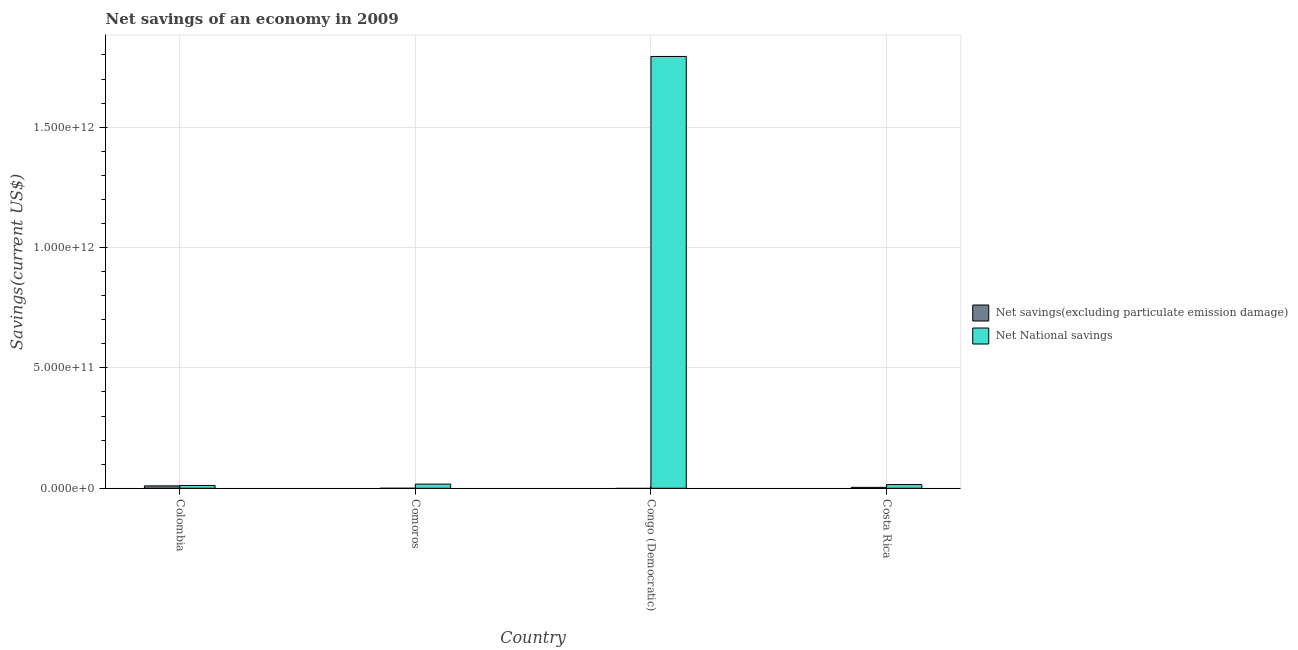Are the number of bars per tick equal to the number of legend labels?
Keep it short and to the point. No. How many bars are there on the 3rd tick from the left?
Give a very brief answer. 1. In how many cases, is the number of bars for a given country not equal to the number of legend labels?
Give a very brief answer. 2. What is the net national savings in Colombia?
Your answer should be compact. 1.17e+1. Across all countries, what is the maximum net savings(excluding particulate emission damage)?
Provide a succinct answer. 9.97e+09. Across all countries, what is the minimum net national savings?
Your response must be concise. 1.17e+1. In which country was the net national savings maximum?
Keep it short and to the point. Congo (Democratic). What is the total net savings(excluding particulate emission damage) in the graph?
Provide a short and direct response. 1.39e+1. What is the difference between the net national savings in Congo (Democratic) and that in Costa Rica?
Keep it short and to the point. 1.78e+12. What is the difference between the net savings(excluding particulate emission damage) in Comoros and the net national savings in Colombia?
Make the answer very short. -1.17e+1. What is the average net savings(excluding particulate emission damage) per country?
Offer a very short reply. 3.47e+09. What is the difference between the net national savings and net savings(excluding particulate emission damage) in Colombia?
Keep it short and to the point. 1.73e+09. In how many countries, is the net national savings greater than 1700000000000 US$?
Offer a terse response. 1. What is the ratio of the net national savings in Colombia to that in Costa Rica?
Offer a terse response. 0.76. Is the difference between the net savings(excluding particulate emission damage) in Colombia and Costa Rica greater than the difference between the net national savings in Colombia and Costa Rica?
Your answer should be compact. Yes. What is the difference between the highest and the second highest net national savings?
Ensure brevity in your answer.  1.78e+12. What is the difference between the highest and the lowest net savings(excluding particulate emission damage)?
Your answer should be very brief. 9.97e+09. In how many countries, is the net national savings greater than the average net national savings taken over all countries?
Provide a succinct answer. 1. How many bars are there?
Your answer should be compact. 6. How many countries are there in the graph?
Keep it short and to the point. 4. What is the difference between two consecutive major ticks on the Y-axis?
Provide a short and direct response. 5.00e+11. Does the graph contain any zero values?
Provide a succinct answer. Yes. Does the graph contain grids?
Your answer should be very brief. Yes. Where does the legend appear in the graph?
Offer a terse response. Center right. How many legend labels are there?
Offer a very short reply. 2. What is the title of the graph?
Your answer should be compact. Net savings of an economy in 2009. Does "Subsidies" appear as one of the legend labels in the graph?
Provide a short and direct response. No. What is the label or title of the X-axis?
Give a very brief answer. Country. What is the label or title of the Y-axis?
Provide a succinct answer. Savings(current US$). What is the Savings(current US$) of Net savings(excluding particulate emission damage) in Colombia?
Keep it short and to the point. 9.97e+09. What is the Savings(current US$) in Net National savings in Colombia?
Your answer should be compact. 1.17e+1. What is the Savings(current US$) in Net savings(excluding particulate emission damage) in Comoros?
Offer a terse response. 0. What is the Savings(current US$) in Net National savings in Comoros?
Offer a very short reply. 1.74e+1. What is the Savings(current US$) in Net savings(excluding particulate emission damage) in Congo (Democratic)?
Offer a terse response. 0. What is the Savings(current US$) in Net National savings in Congo (Democratic)?
Your answer should be very brief. 1.79e+12. What is the Savings(current US$) in Net savings(excluding particulate emission damage) in Costa Rica?
Provide a short and direct response. 3.89e+09. What is the Savings(current US$) of Net National savings in Costa Rica?
Make the answer very short. 1.53e+1. Across all countries, what is the maximum Savings(current US$) of Net savings(excluding particulate emission damage)?
Give a very brief answer. 9.97e+09. Across all countries, what is the maximum Savings(current US$) in Net National savings?
Your answer should be compact. 1.79e+12. Across all countries, what is the minimum Savings(current US$) of Net savings(excluding particulate emission damage)?
Provide a short and direct response. 0. Across all countries, what is the minimum Savings(current US$) in Net National savings?
Your answer should be compact. 1.17e+1. What is the total Savings(current US$) in Net savings(excluding particulate emission damage) in the graph?
Make the answer very short. 1.39e+1. What is the total Savings(current US$) of Net National savings in the graph?
Ensure brevity in your answer.  1.84e+12. What is the difference between the Savings(current US$) in Net National savings in Colombia and that in Comoros?
Offer a terse response. -5.72e+09. What is the difference between the Savings(current US$) in Net National savings in Colombia and that in Congo (Democratic)?
Make the answer very short. -1.78e+12. What is the difference between the Savings(current US$) of Net savings(excluding particulate emission damage) in Colombia and that in Costa Rica?
Ensure brevity in your answer.  6.09e+09. What is the difference between the Savings(current US$) in Net National savings in Colombia and that in Costa Rica?
Make the answer very short. -3.64e+09. What is the difference between the Savings(current US$) in Net National savings in Comoros and that in Congo (Democratic)?
Offer a very short reply. -1.78e+12. What is the difference between the Savings(current US$) of Net National savings in Comoros and that in Costa Rica?
Keep it short and to the point. 2.08e+09. What is the difference between the Savings(current US$) in Net National savings in Congo (Democratic) and that in Costa Rica?
Provide a short and direct response. 1.78e+12. What is the difference between the Savings(current US$) in Net savings(excluding particulate emission damage) in Colombia and the Savings(current US$) in Net National savings in Comoros?
Keep it short and to the point. -7.46e+09. What is the difference between the Savings(current US$) in Net savings(excluding particulate emission damage) in Colombia and the Savings(current US$) in Net National savings in Congo (Democratic)?
Provide a short and direct response. -1.78e+12. What is the difference between the Savings(current US$) of Net savings(excluding particulate emission damage) in Colombia and the Savings(current US$) of Net National savings in Costa Rica?
Your answer should be compact. -5.37e+09. What is the average Savings(current US$) in Net savings(excluding particulate emission damage) per country?
Provide a short and direct response. 3.47e+09. What is the average Savings(current US$) in Net National savings per country?
Offer a terse response. 4.60e+11. What is the difference between the Savings(current US$) of Net savings(excluding particulate emission damage) and Savings(current US$) of Net National savings in Colombia?
Give a very brief answer. -1.73e+09. What is the difference between the Savings(current US$) of Net savings(excluding particulate emission damage) and Savings(current US$) of Net National savings in Costa Rica?
Offer a terse response. -1.15e+1. What is the ratio of the Savings(current US$) of Net National savings in Colombia to that in Comoros?
Offer a terse response. 0.67. What is the ratio of the Savings(current US$) in Net National savings in Colombia to that in Congo (Democratic)?
Make the answer very short. 0.01. What is the ratio of the Savings(current US$) in Net savings(excluding particulate emission damage) in Colombia to that in Costa Rica?
Ensure brevity in your answer.  2.57. What is the ratio of the Savings(current US$) in Net National savings in Colombia to that in Costa Rica?
Ensure brevity in your answer.  0.76. What is the ratio of the Savings(current US$) in Net National savings in Comoros to that in Congo (Democratic)?
Provide a succinct answer. 0.01. What is the ratio of the Savings(current US$) in Net National savings in Comoros to that in Costa Rica?
Provide a short and direct response. 1.14. What is the ratio of the Savings(current US$) of Net National savings in Congo (Democratic) to that in Costa Rica?
Provide a short and direct response. 116.87. What is the difference between the highest and the second highest Savings(current US$) in Net National savings?
Give a very brief answer. 1.78e+12. What is the difference between the highest and the lowest Savings(current US$) of Net savings(excluding particulate emission damage)?
Provide a short and direct response. 9.97e+09. What is the difference between the highest and the lowest Savings(current US$) of Net National savings?
Ensure brevity in your answer.  1.78e+12. 